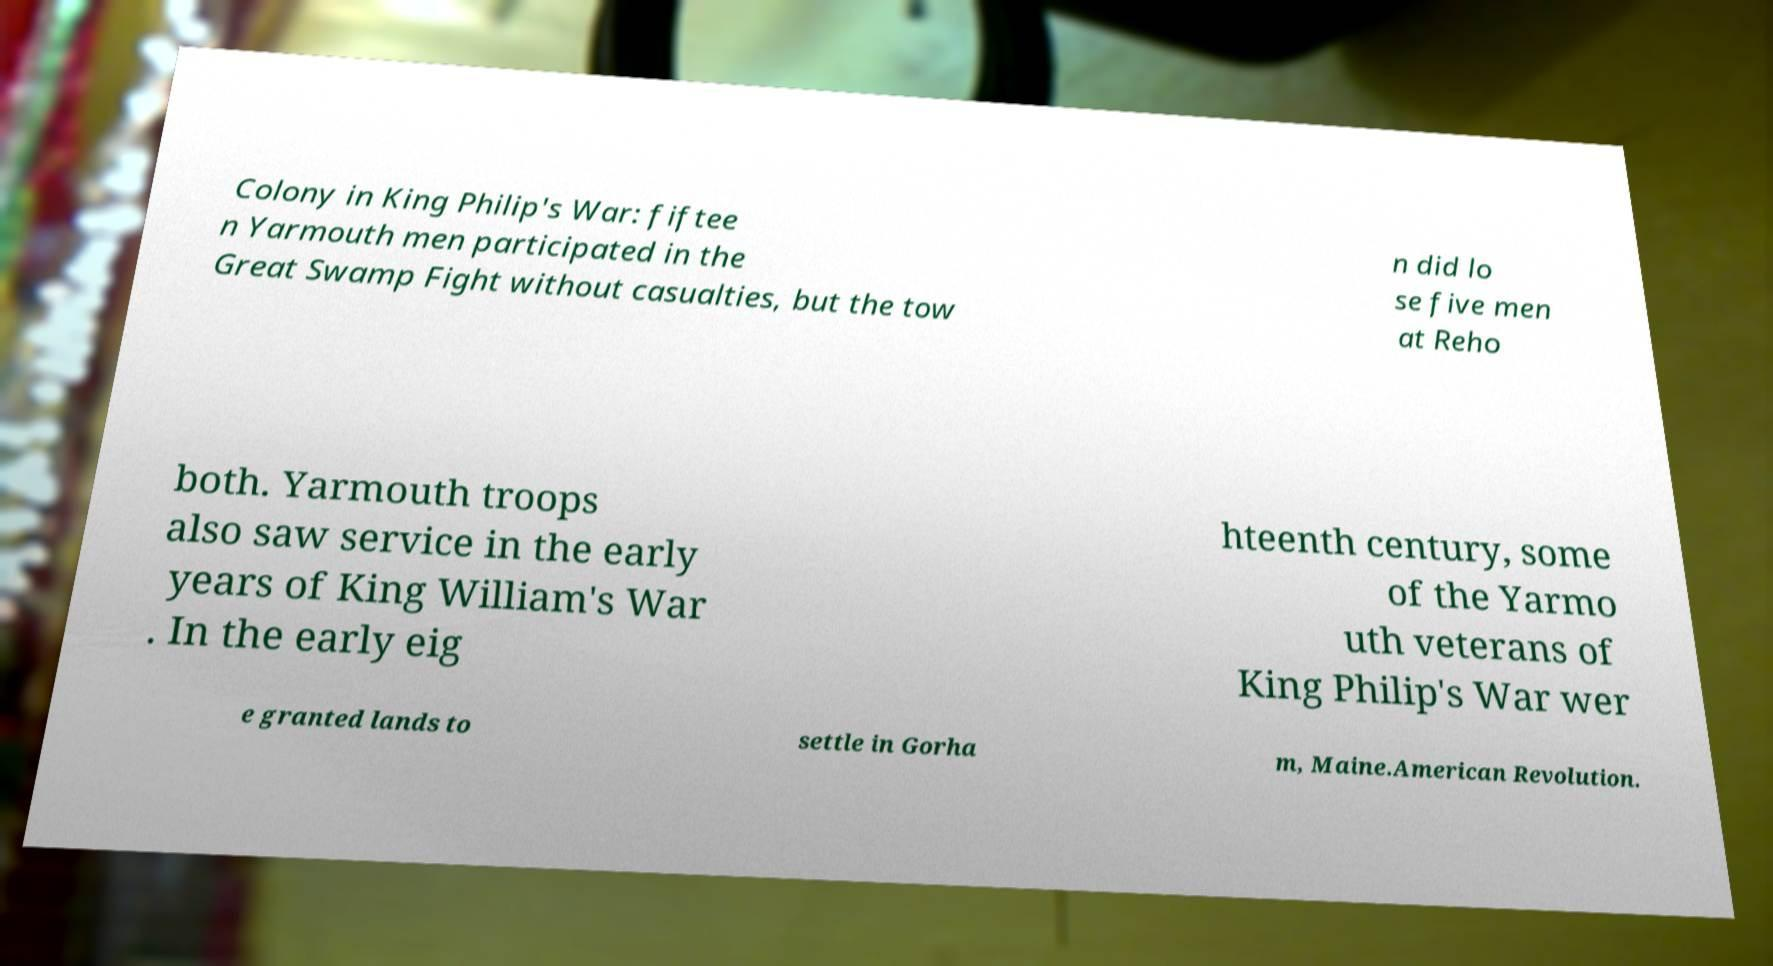For documentation purposes, I need the text within this image transcribed. Could you provide that? Colony in King Philip's War: fiftee n Yarmouth men participated in the Great Swamp Fight without casualties, but the tow n did lo se five men at Reho both. Yarmouth troops also saw service in the early years of King William's War . In the early eig hteenth century, some of the Yarmo uth veterans of King Philip's War wer e granted lands to settle in Gorha m, Maine.American Revolution. 